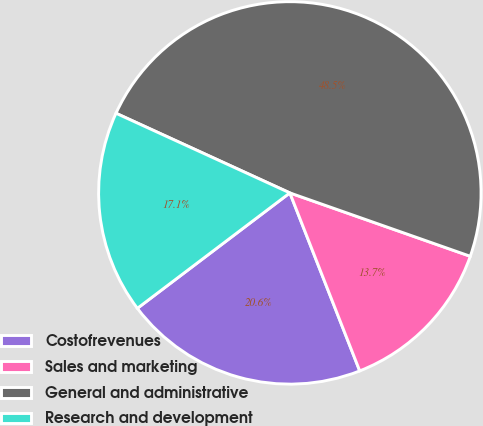Convert chart. <chart><loc_0><loc_0><loc_500><loc_500><pie_chart><fcel>Costofrevenues<fcel>Sales and marketing<fcel>General and administrative<fcel>Research and development<nl><fcel>20.64%<fcel>13.67%<fcel>48.54%<fcel>17.15%<nl></chart> 